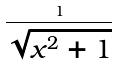<formula> <loc_0><loc_0><loc_500><loc_500>\frac { 1 } { \sqrt { x ^ { 2 } + 1 } }</formula> 